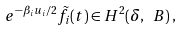Convert formula to latex. <formula><loc_0><loc_0><loc_500><loc_500>e ^ { - \beta _ { i } u _ { i } / 2 } \tilde { f } _ { i } ( t ) \in H ^ { 2 } ( \delta , \ B ) \, ,</formula> 